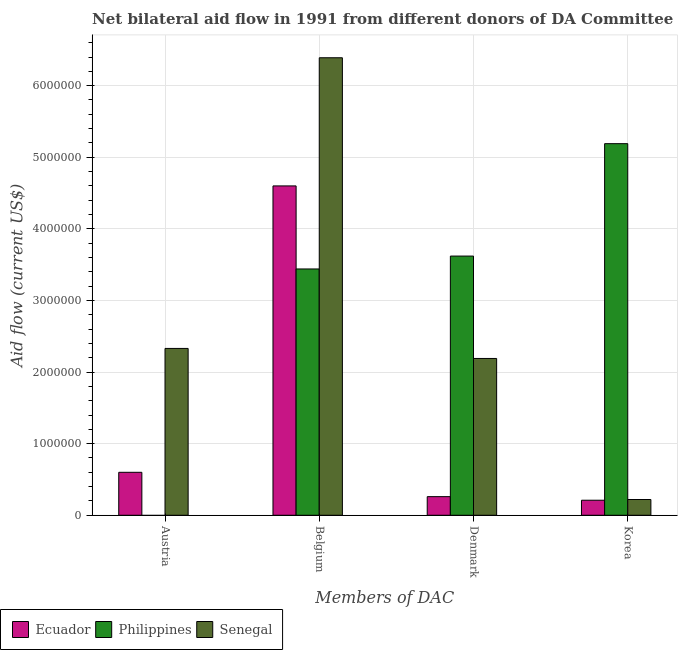How many groups of bars are there?
Your response must be concise. 4. How many bars are there on the 2nd tick from the left?
Offer a very short reply. 3. What is the amount of aid given by belgium in Ecuador?
Give a very brief answer. 4.60e+06. Across all countries, what is the maximum amount of aid given by korea?
Make the answer very short. 5.19e+06. Across all countries, what is the minimum amount of aid given by korea?
Your answer should be compact. 2.10e+05. In which country was the amount of aid given by korea maximum?
Make the answer very short. Philippines. What is the total amount of aid given by belgium in the graph?
Give a very brief answer. 1.44e+07. What is the difference between the amount of aid given by korea in Philippines and that in Ecuador?
Offer a very short reply. 4.98e+06. What is the difference between the amount of aid given by korea in Philippines and the amount of aid given by austria in Senegal?
Provide a short and direct response. 2.86e+06. What is the average amount of aid given by korea per country?
Your answer should be compact. 1.87e+06. What is the difference between the amount of aid given by austria and amount of aid given by korea in Senegal?
Keep it short and to the point. 2.11e+06. What is the ratio of the amount of aid given by korea in Ecuador to that in Senegal?
Your answer should be very brief. 0.95. What is the difference between the highest and the second highest amount of aid given by korea?
Provide a succinct answer. 4.97e+06. What is the difference between the highest and the lowest amount of aid given by korea?
Provide a short and direct response. 4.98e+06. Is it the case that in every country, the sum of the amount of aid given by austria and amount of aid given by belgium is greater than the amount of aid given by denmark?
Offer a terse response. No. How many bars are there?
Offer a terse response. 11. Are all the bars in the graph horizontal?
Provide a succinct answer. No. How many countries are there in the graph?
Your answer should be very brief. 3. How are the legend labels stacked?
Your answer should be very brief. Horizontal. What is the title of the graph?
Keep it short and to the point. Net bilateral aid flow in 1991 from different donors of DA Committee. Does "Australia" appear as one of the legend labels in the graph?
Your answer should be very brief. No. What is the label or title of the X-axis?
Give a very brief answer. Members of DAC. What is the Aid flow (current US$) in Senegal in Austria?
Keep it short and to the point. 2.33e+06. What is the Aid flow (current US$) in Ecuador in Belgium?
Provide a succinct answer. 4.60e+06. What is the Aid flow (current US$) in Philippines in Belgium?
Your answer should be very brief. 3.44e+06. What is the Aid flow (current US$) of Senegal in Belgium?
Provide a succinct answer. 6.39e+06. What is the Aid flow (current US$) in Ecuador in Denmark?
Provide a succinct answer. 2.60e+05. What is the Aid flow (current US$) in Philippines in Denmark?
Make the answer very short. 3.62e+06. What is the Aid flow (current US$) of Senegal in Denmark?
Offer a very short reply. 2.19e+06. What is the Aid flow (current US$) of Philippines in Korea?
Provide a short and direct response. 5.19e+06. Across all Members of DAC, what is the maximum Aid flow (current US$) in Ecuador?
Offer a terse response. 4.60e+06. Across all Members of DAC, what is the maximum Aid flow (current US$) in Philippines?
Your answer should be very brief. 5.19e+06. Across all Members of DAC, what is the maximum Aid flow (current US$) in Senegal?
Make the answer very short. 6.39e+06. Across all Members of DAC, what is the minimum Aid flow (current US$) in Ecuador?
Your response must be concise. 2.10e+05. Across all Members of DAC, what is the minimum Aid flow (current US$) in Philippines?
Ensure brevity in your answer.  0. What is the total Aid flow (current US$) in Ecuador in the graph?
Provide a succinct answer. 5.67e+06. What is the total Aid flow (current US$) of Philippines in the graph?
Your response must be concise. 1.22e+07. What is the total Aid flow (current US$) in Senegal in the graph?
Keep it short and to the point. 1.11e+07. What is the difference between the Aid flow (current US$) of Ecuador in Austria and that in Belgium?
Provide a short and direct response. -4.00e+06. What is the difference between the Aid flow (current US$) of Senegal in Austria and that in Belgium?
Offer a terse response. -4.06e+06. What is the difference between the Aid flow (current US$) of Ecuador in Austria and that in Denmark?
Your answer should be compact. 3.40e+05. What is the difference between the Aid flow (current US$) of Senegal in Austria and that in Denmark?
Ensure brevity in your answer.  1.40e+05. What is the difference between the Aid flow (current US$) of Ecuador in Austria and that in Korea?
Your response must be concise. 3.90e+05. What is the difference between the Aid flow (current US$) of Senegal in Austria and that in Korea?
Your answer should be very brief. 2.11e+06. What is the difference between the Aid flow (current US$) in Ecuador in Belgium and that in Denmark?
Provide a succinct answer. 4.34e+06. What is the difference between the Aid flow (current US$) in Philippines in Belgium and that in Denmark?
Make the answer very short. -1.80e+05. What is the difference between the Aid flow (current US$) of Senegal in Belgium and that in Denmark?
Your answer should be compact. 4.20e+06. What is the difference between the Aid flow (current US$) of Ecuador in Belgium and that in Korea?
Provide a short and direct response. 4.39e+06. What is the difference between the Aid flow (current US$) of Philippines in Belgium and that in Korea?
Provide a short and direct response. -1.75e+06. What is the difference between the Aid flow (current US$) in Senegal in Belgium and that in Korea?
Your response must be concise. 6.17e+06. What is the difference between the Aid flow (current US$) of Ecuador in Denmark and that in Korea?
Provide a short and direct response. 5.00e+04. What is the difference between the Aid flow (current US$) of Philippines in Denmark and that in Korea?
Ensure brevity in your answer.  -1.57e+06. What is the difference between the Aid flow (current US$) in Senegal in Denmark and that in Korea?
Provide a succinct answer. 1.97e+06. What is the difference between the Aid flow (current US$) in Ecuador in Austria and the Aid flow (current US$) in Philippines in Belgium?
Offer a very short reply. -2.84e+06. What is the difference between the Aid flow (current US$) in Ecuador in Austria and the Aid flow (current US$) in Senegal in Belgium?
Your answer should be compact. -5.79e+06. What is the difference between the Aid flow (current US$) in Ecuador in Austria and the Aid flow (current US$) in Philippines in Denmark?
Provide a succinct answer. -3.02e+06. What is the difference between the Aid flow (current US$) of Ecuador in Austria and the Aid flow (current US$) of Senegal in Denmark?
Keep it short and to the point. -1.59e+06. What is the difference between the Aid flow (current US$) of Ecuador in Austria and the Aid flow (current US$) of Philippines in Korea?
Your response must be concise. -4.59e+06. What is the difference between the Aid flow (current US$) of Ecuador in Belgium and the Aid flow (current US$) of Philippines in Denmark?
Give a very brief answer. 9.80e+05. What is the difference between the Aid flow (current US$) in Ecuador in Belgium and the Aid flow (current US$) in Senegal in Denmark?
Keep it short and to the point. 2.41e+06. What is the difference between the Aid flow (current US$) of Philippines in Belgium and the Aid flow (current US$) of Senegal in Denmark?
Make the answer very short. 1.25e+06. What is the difference between the Aid flow (current US$) in Ecuador in Belgium and the Aid flow (current US$) in Philippines in Korea?
Your answer should be compact. -5.90e+05. What is the difference between the Aid flow (current US$) in Ecuador in Belgium and the Aid flow (current US$) in Senegal in Korea?
Provide a short and direct response. 4.38e+06. What is the difference between the Aid flow (current US$) of Philippines in Belgium and the Aid flow (current US$) of Senegal in Korea?
Ensure brevity in your answer.  3.22e+06. What is the difference between the Aid flow (current US$) of Ecuador in Denmark and the Aid flow (current US$) of Philippines in Korea?
Your response must be concise. -4.93e+06. What is the difference between the Aid flow (current US$) in Ecuador in Denmark and the Aid flow (current US$) in Senegal in Korea?
Ensure brevity in your answer.  4.00e+04. What is the difference between the Aid flow (current US$) in Philippines in Denmark and the Aid flow (current US$) in Senegal in Korea?
Your response must be concise. 3.40e+06. What is the average Aid flow (current US$) of Ecuador per Members of DAC?
Keep it short and to the point. 1.42e+06. What is the average Aid flow (current US$) in Philippines per Members of DAC?
Your response must be concise. 3.06e+06. What is the average Aid flow (current US$) of Senegal per Members of DAC?
Your response must be concise. 2.78e+06. What is the difference between the Aid flow (current US$) of Ecuador and Aid flow (current US$) of Senegal in Austria?
Your answer should be compact. -1.73e+06. What is the difference between the Aid flow (current US$) in Ecuador and Aid flow (current US$) in Philippines in Belgium?
Make the answer very short. 1.16e+06. What is the difference between the Aid flow (current US$) in Ecuador and Aid flow (current US$) in Senegal in Belgium?
Provide a short and direct response. -1.79e+06. What is the difference between the Aid flow (current US$) of Philippines and Aid flow (current US$) of Senegal in Belgium?
Your answer should be very brief. -2.95e+06. What is the difference between the Aid flow (current US$) in Ecuador and Aid flow (current US$) in Philippines in Denmark?
Offer a terse response. -3.36e+06. What is the difference between the Aid flow (current US$) of Ecuador and Aid flow (current US$) of Senegal in Denmark?
Make the answer very short. -1.93e+06. What is the difference between the Aid flow (current US$) in Philippines and Aid flow (current US$) in Senegal in Denmark?
Your answer should be compact. 1.43e+06. What is the difference between the Aid flow (current US$) in Ecuador and Aid flow (current US$) in Philippines in Korea?
Offer a very short reply. -4.98e+06. What is the difference between the Aid flow (current US$) of Ecuador and Aid flow (current US$) of Senegal in Korea?
Your answer should be compact. -10000. What is the difference between the Aid flow (current US$) of Philippines and Aid flow (current US$) of Senegal in Korea?
Provide a short and direct response. 4.97e+06. What is the ratio of the Aid flow (current US$) of Ecuador in Austria to that in Belgium?
Give a very brief answer. 0.13. What is the ratio of the Aid flow (current US$) of Senegal in Austria to that in Belgium?
Provide a succinct answer. 0.36. What is the ratio of the Aid flow (current US$) of Ecuador in Austria to that in Denmark?
Your response must be concise. 2.31. What is the ratio of the Aid flow (current US$) of Senegal in Austria to that in Denmark?
Provide a succinct answer. 1.06. What is the ratio of the Aid flow (current US$) in Ecuador in Austria to that in Korea?
Offer a terse response. 2.86. What is the ratio of the Aid flow (current US$) of Senegal in Austria to that in Korea?
Offer a very short reply. 10.59. What is the ratio of the Aid flow (current US$) of Ecuador in Belgium to that in Denmark?
Keep it short and to the point. 17.69. What is the ratio of the Aid flow (current US$) of Philippines in Belgium to that in Denmark?
Your answer should be very brief. 0.95. What is the ratio of the Aid flow (current US$) in Senegal in Belgium to that in Denmark?
Provide a short and direct response. 2.92. What is the ratio of the Aid flow (current US$) of Ecuador in Belgium to that in Korea?
Provide a short and direct response. 21.9. What is the ratio of the Aid flow (current US$) of Philippines in Belgium to that in Korea?
Offer a terse response. 0.66. What is the ratio of the Aid flow (current US$) of Senegal in Belgium to that in Korea?
Offer a terse response. 29.05. What is the ratio of the Aid flow (current US$) in Ecuador in Denmark to that in Korea?
Your answer should be compact. 1.24. What is the ratio of the Aid flow (current US$) in Philippines in Denmark to that in Korea?
Keep it short and to the point. 0.7. What is the ratio of the Aid flow (current US$) of Senegal in Denmark to that in Korea?
Provide a succinct answer. 9.95. What is the difference between the highest and the second highest Aid flow (current US$) in Philippines?
Provide a succinct answer. 1.57e+06. What is the difference between the highest and the second highest Aid flow (current US$) in Senegal?
Give a very brief answer. 4.06e+06. What is the difference between the highest and the lowest Aid flow (current US$) in Ecuador?
Make the answer very short. 4.39e+06. What is the difference between the highest and the lowest Aid flow (current US$) of Philippines?
Your answer should be compact. 5.19e+06. What is the difference between the highest and the lowest Aid flow (current US$) of Senegal?
Provide a succinct answer. 6.17e+06. 